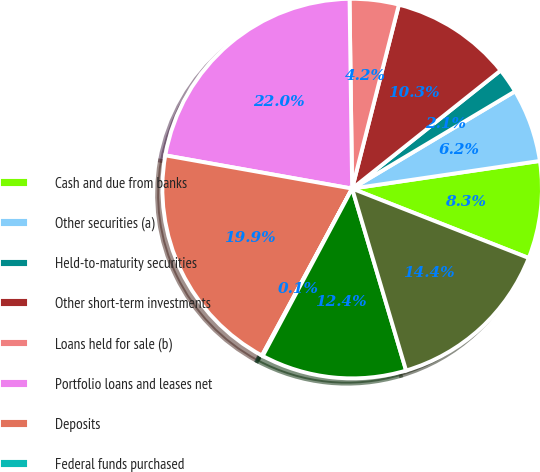<chart> <loc_0><loc_0><loc_500><loc_500><pie_chart><fcel>Cash and due from banks<fcel>Other securities (a)<fcel>Held-to-maturity securities<fcel>Other short-term investments<fcel>Loans held for sale (b)<fcel>Portfolio loans and leases net<fcel>Deposits<fcel>Federal funds purchased<fcel>Other short-term borrowings<fcel>Long-term debt<nl><fcel>8.29%<fcel>6.24%<fcel>2.13%<fcel>10.34%<fcel>4.18%<fcel>21.98%<fcel>19.92%<fcel>0.07%<fcel>12.4%<fcel>14.45%<nl></chart> 